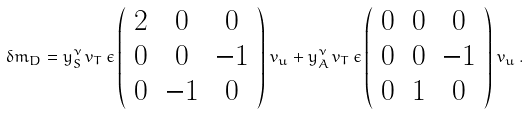<formula> <loc_0><loc_0><loc_500><loc_500>\delta m _ { D } = y _ { S } ^ { \nu } \, v _ { T } \, \epsilon \left ( \begin{array} { c c c } 2 & 0 & 0 \\ 0 & 0 & - 1 \\ 0 & - 1 & 0 \end{array} \right ) \, v _ { u } + y _ { A } ^ { \nu } \, v _ { T } \, \epsilon \left ( \begin{array} { c c c } 0 & 0 & 0 \\ 0 & 0 & - 1 \\ 0 & 1 & 0 \end{array} \right ) \, v _ { u } \, .</formula> 